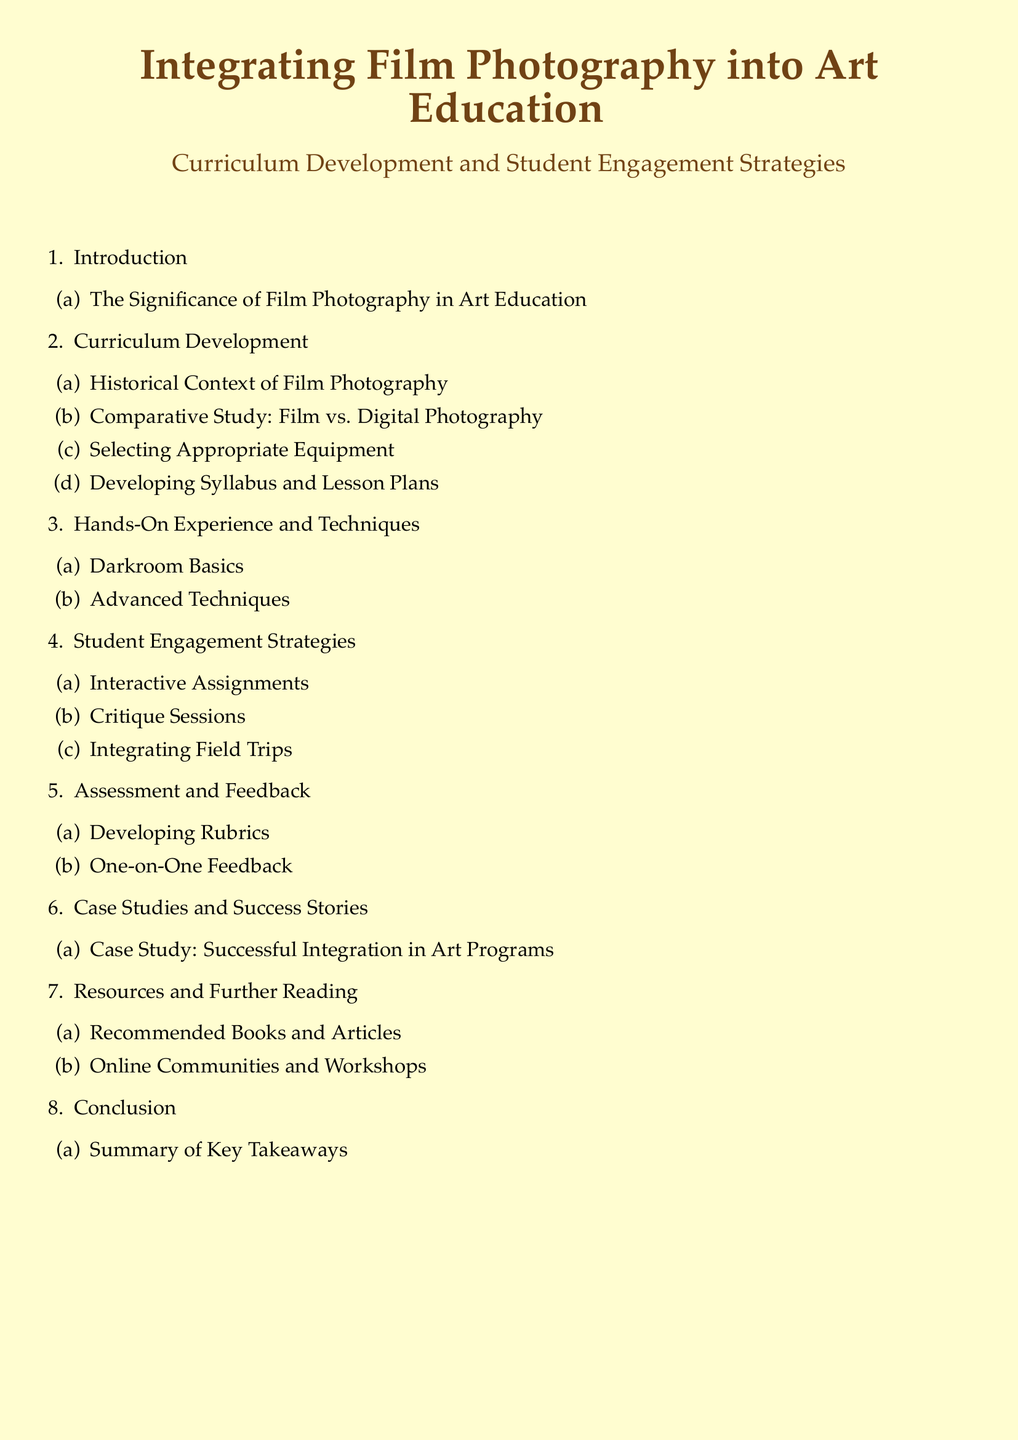What is the title of the document? The title of the document is prominently displayed at the beginning, clearly indicating the focus on film photography and art education.
Answer: Integrating Film Photography into Art Education How many main sections are there in the Table of Contents? The main sections are counted in the enumerated list at the beginning, revealing the structure of the document.
Answer: 8 What is the first subsection under Curriculum Development? The subsections provide detailed topics under main sections, allowing insight into the curriculum's focus.
Answer: Historical Context of Film Photography Name a strategy mentioned for student engagement. This information is listed under the Student Engagement Strategies section, showcasing methods to enhance student involvement.
Answer: Interactive Assignments What is one requirement for hands-on techniques? The list of hands-on experience topics indicates areas of focus necessary for practical learning.
Answer: Darkroom Basics How is assessment handled in the curriculum? The Assessment and Feedback section describes the approach taken to evaluate student performance and learning.
Answer: Developing Rubrics What is included in the Resources and Further Reading section? This section aims to guide readers towards additional materials and communities supporting film photography education.
Answer: Recommended Books and Articles What is a key takeaway mentioned in the conclusion? The Conclusion section summarizes the main insights drawn from the entire document, highlighting essential points for readers.
Answer: Summary of Key Takeaways 